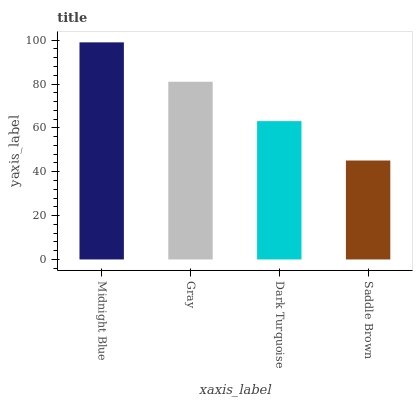Is Saddle Brown the minimum?
Answer yes or no. Yes. Is Midnight Blue the maximum?
Answer yes or no. Yes. Is Gray the minimum?
Answer yes or no. No. Is Gray the maximum?
Answer yes or no. No. Is Midnight Blue greater than Gray?
Answer yes or no. Yes. Is Gray less than Midnight Blue?
Answer yes or no. Yes. Is Gray greater than Midnight Blue?
Answer yes or no. No. Is Midnight Blue less than Gray?
Answer yes or no. No. Is Gray the high median?
Answer yes or no. Yes. Is Dark Turquoise the low median?
Answer yes or no. Yes. Is Midnight Blue the high median?
Answer yes or no. No. Is Saddle Brown the low median?
Answer yes or no. No. 